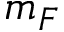Convert formula to latex. <formula><loc_0><loc_0><loc_500><loc_500>m _ { F }</formula> 